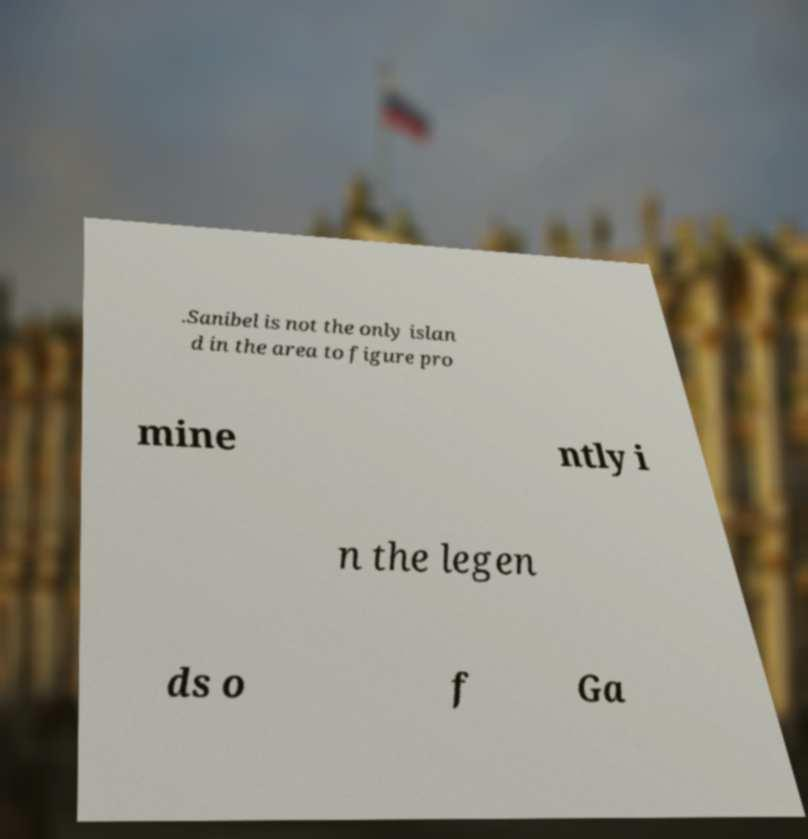Please read and relay the text visible in this image. What does it say? .Sanibel is not the only islan d in the area to figure pro mine ntly i n the legen ds o f Ga 